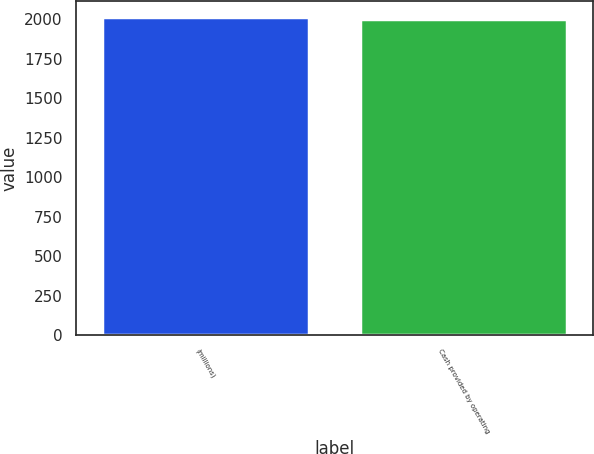Convert chart to OTSL. <chart><loc_0><loc_0><loc_500><loc_500><bar_chart><fcel>(millions)<fcel>Cash provided by operating<nl><fcel>2015<fcel>1999.8<nl></chart> 